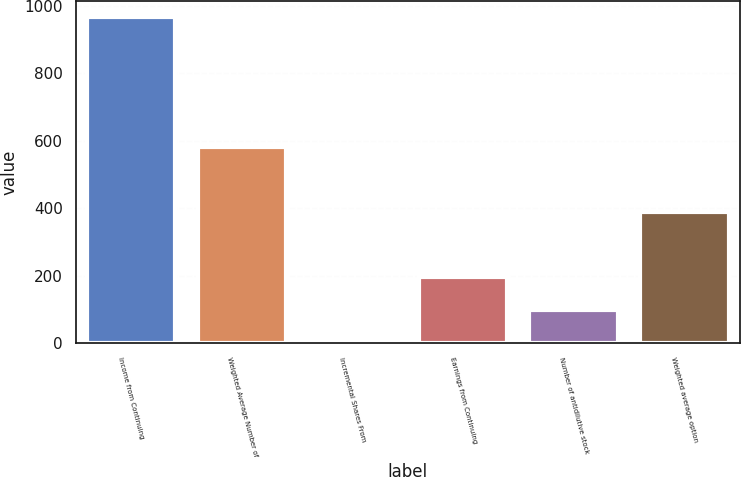Convert chart. <chart><loc_0><loc_0><loc_500><loc_500><bar_chart><fcel>Income from Continuing<fcel>Weighted Average Number of<fcel>Incremental Shares From<fcel>Earnings from Continuing<fcel>Number of antidilutive stock<fcel>Weighted average option<nl><fcel>965<fcel>579.8<fcel>2<fcel>194.6<fcel>98.3<fcel>387.2<nl></chart> 